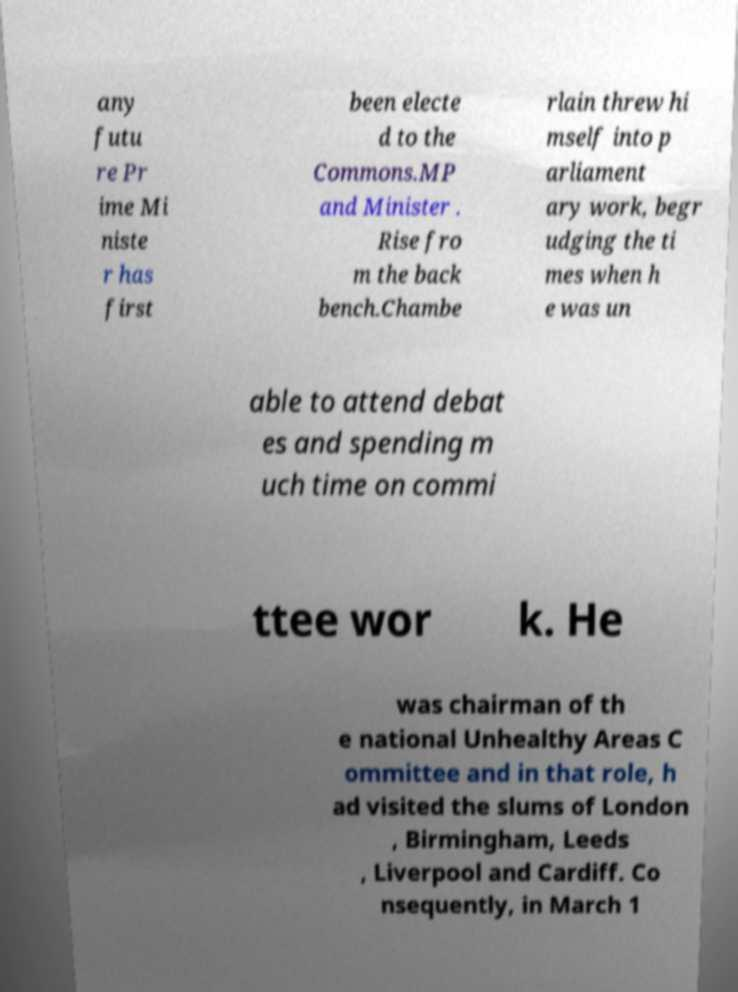Please identify and transcribe the text found in this image. any futu re Pr ime Mi niste r has first been electe d to the Commons.MP and Minister . Rise fro m the back bench.Chambe rlain threw hi mself into p arliament ary work, begr udging the ti mes when h e was un able to attend debat es and spending m uch time on commi ttee wor k. He was chairman of th e national Unhealthy Areas C ommittee and in that role, h ad visited the slums of London , Birmingham, Leeds , Liverpool and Cardiff. Co nsequently, in March 1 